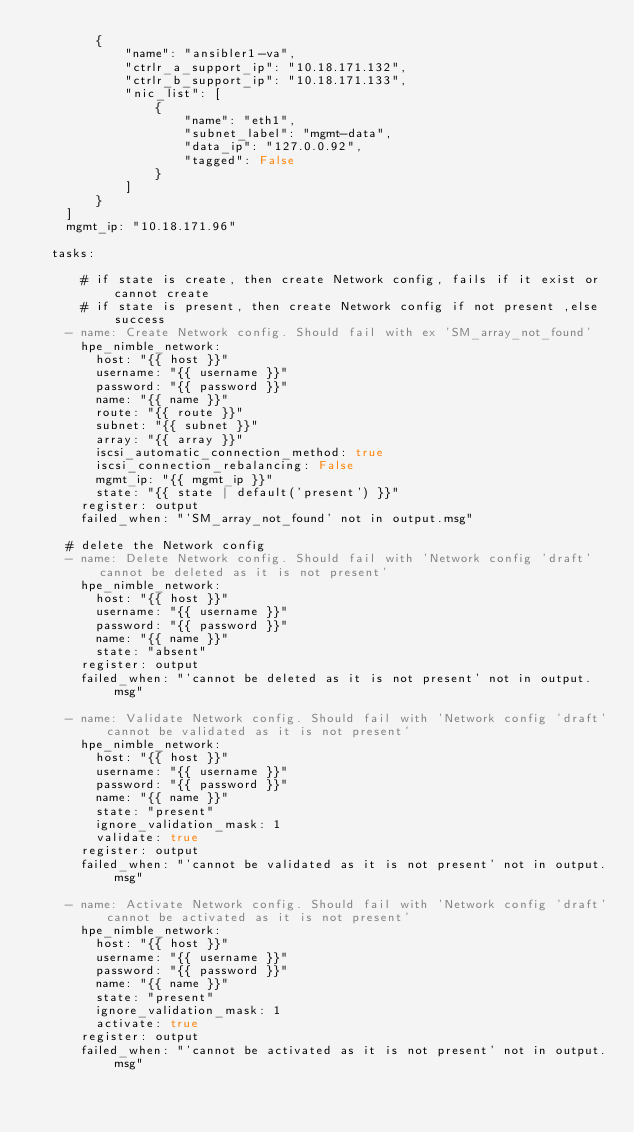<code> <loc_0><loc_0><loc_500><loc_500><_YAML_>        {
            "name": "ansibler1-va",
            "ctrlr_a_support_ip": "10.18.171.132",
            "ctrlr_b_support_ip": "10.18.171.133",
            "nic_list": [
                {
                    "name": "eth1",
                    "subnet_label": "mgmt-data",
                    "data_ip": "127.0.0.92",
                    "tagged": False
                }
            ]
        }
    ]
    mgmt_ip: "10.18.171.96"

  tasks:

      # if state is create, then create Network config, fails if it exist or cannot create
      # if state is present, then create Network config if not present ,else success
    - name: Create Network config. Should fail with ex 'SM_array_not_found'
      hpe_nimble_network:
        host: "{{ host }}"
        username: "{{ username }}"
        password: "{{ password }}"
        name: "{{ name }}"
        route: "{{ route }}"
        subnet: "{{ subnet }}"
        array: "{{ array }}"
        iscsi_automatic_connection_method: true
        iscsi_connection_rebalancing: False
        mgmt_ip: "{{ mgmt_ip }}"
        state: "{{ state | default('present') }}"
      register: output
      failed_when: "'SM_array_not_found' not in output.msg"

    # delete the Network config
    - name: Delete Network config. Should fail with 'Network config 'draft' cannot be deleted as it is not present'
      hpe_nimble_network:
        host: "{{ host }}"
        username: "{{ username }}"
        password: "{{ password }}"
        name: "{{ name }}"
        state: "absent"
      register: output
      failed_when: "'cannot be deleted as it is not present' not in output.msg"

    - name: Validate Network config. Should fail with 'Network config 'draft' cannot be validated as it is not present'
      hpe_nimble_network:
        host: "{{ host }}"
        username: "{{ username }}"
        password: "{{ password }}"
        name: "{{ name }}"
        state: "present"
        ignore_validation_mask: 1
        validate: true
      register: output
      failed_when: "'cannot be validated as it is not present' not in output.msg"

    - name: Activate Network config. Should fail with 'Network config 'draft' cannot be activated as it is not present'
      hpe_nimble_network:
        host: "{{ host }}"
        username: "{{ username }}"
        password: "{{ password }}"
        name: "{{ name }}"
        state: "present"
        ignore_validation_mask: 1
        activate: true
      register: output
      failed_when: "'cannot be activated as it is not present' not in output.msg"</code> 